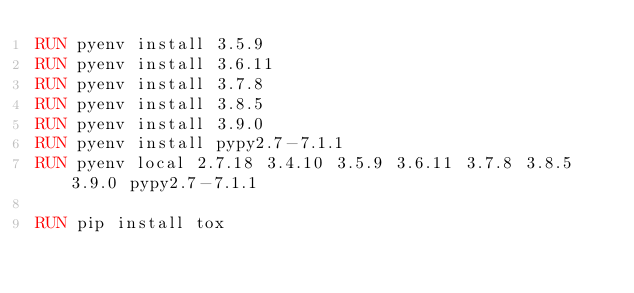<code> <loc_0><loc_0><loc_500><loc_500><_Dockerfile_>RUN pyenv install 3.5.9
RUN pyenv install 3.6.11
RUN pyenv install 3.7.8
RUN pyenv install 3.8.5
RUN pyenv install 3.9.0
RUN pyenv install pypy2.7-7.1.1
RUN pyenv local 2.7.18 3.4.10 3.5.9 3.6.11 3.7.8 3.8.5 3.9.0 pypy2.7-7.1.1

RUN pip install tox
</code> 